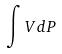<formula> <loc_0><loc_0><loc_500><loc_500>\int V d P</formula> 